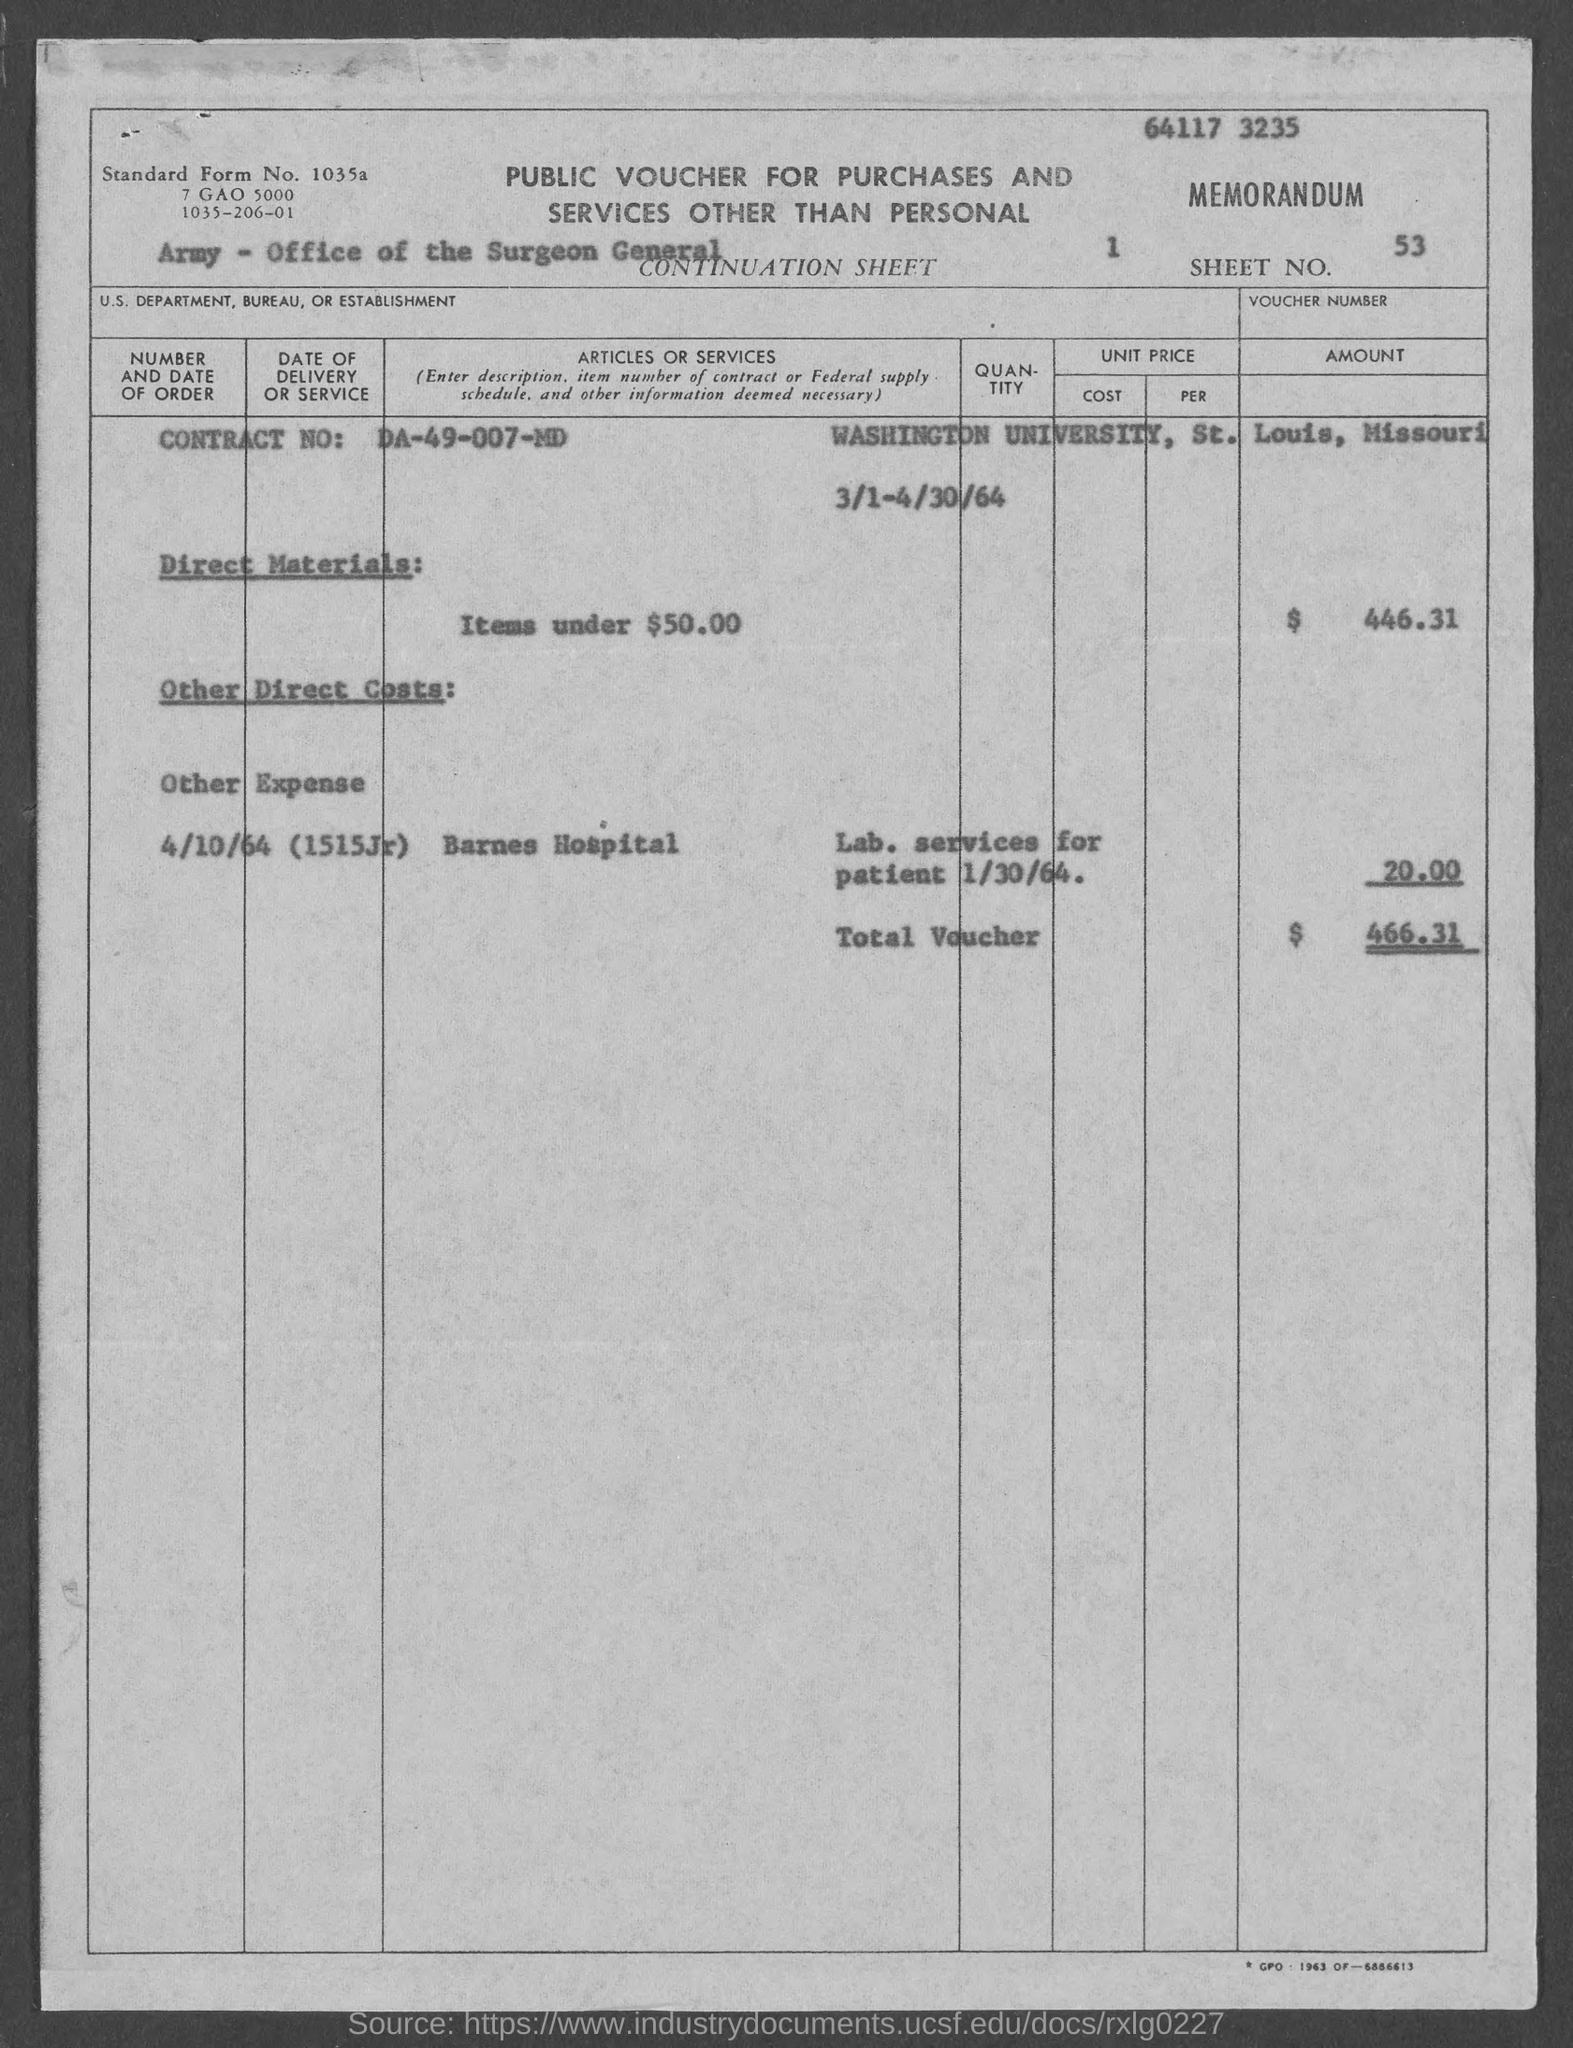Identify some key points in this picture. The given page contains information about a sheet number, which is 53. The name of the university mentioned in the given form is Washington University. The amount for direct materials, as mentioned in the provided form, is $446.31. The amount of other expenses mentioned in the given form is 20... The contract number mentioned in the given form is DA-49-007-MD.. 